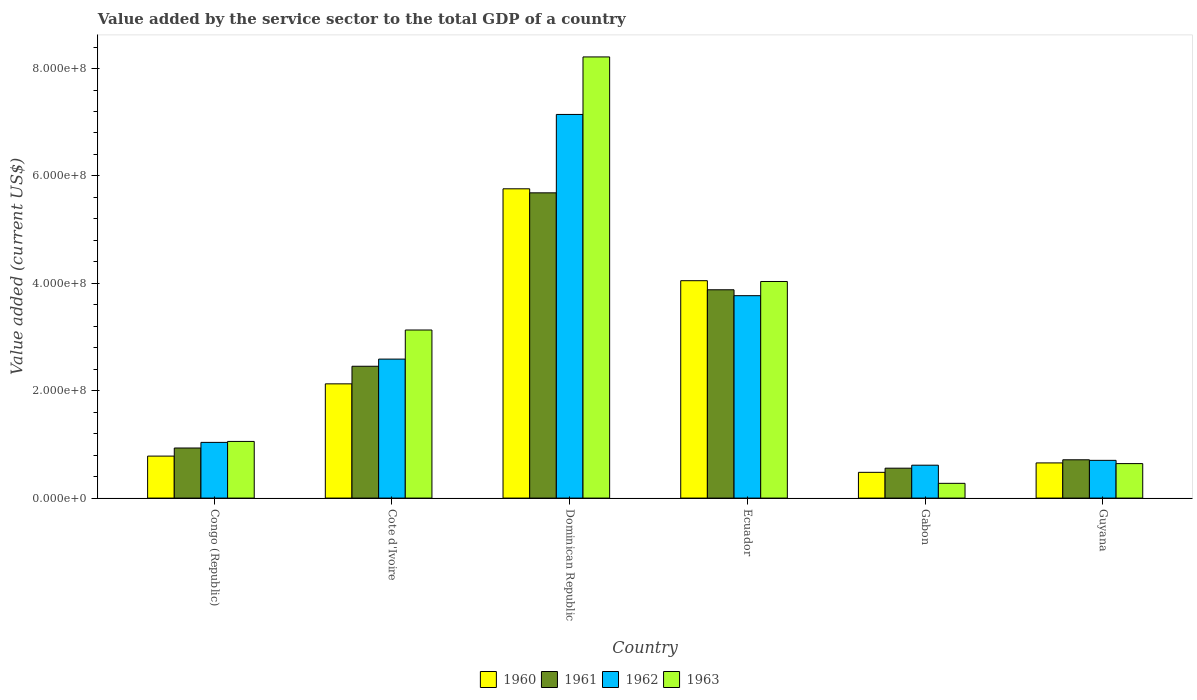Are the number of bars per tick equal to the number of legend labels?
Provide a succinct answer. Yes. Are the number of bars on each tick of the X-axis equal?
Offer a very short reply. Yes. How many bars are there on the 1st tick from the left?
Make the answer very short. 4. What is the label of the 1st group of bars from the left?
Provide a succinct answer. Congo (Republic). What is the value added by the service sector to the total GDP in 1961 in Guyana?
Your answer should be compact. 7.13e+07. Across all countries, what is the maximum value added by the service sector to the total GDP in 1962?
Provide a succinct answer. 7.14e+08. Across all countries, what is the minimum value added by the service sector to the total GDP in 1960?
Make the answer very short. 4.80e+07. In which country was the value added by the service sector to the total GDP in 1963 maximum?
Provide a succinct answer. Dominican Republic. In which country was the value added by the service sector to the total GDP in 1961 minimum?
Your response must be concise. Gabon. What is the total value added by the service sector to the total GDP in 1960 in the graph?
Your response must be concise. 1.39e+09. What is the difference between the value added by the service sector to the total GDP in 1962 in Congo (Republic) and that in Guyana?
Ensure brevity in your answer.  3.35e+07. What is the difference between the value added by the service sector to the total GDP in 1960 in Congo (Republic) and the value added by the service sector to the total GDP in 1962 in Cote d'Ivoire?
Your answer should be very brief. -1.81e+08. What is the average value added by the service sector to the total GDP in 1962 per country?
Your answer should be compact. 2.64e+08. What is the difference between the value added by the service sector to the total GDP of/in 1962 and value added by the service sector to the total GDP of/in 1960 in Congo (Republic)?
Make the answer very short. 2.55e+07. What is the ratio of the value added by the service sector to the total GDP in 1962 in Dominican Republic to that in Ecuador?
Your answer should be compact. 1.9. Is the value added by the service sector to the total GDP in 1961 in Congo (Republic) less than that in Cote d'Ivoire?
Provide a short and direct response. Yes. What is the difference between the highest and the second highest value added by the service sector to the total GDP in 1960?
Ensure brevity in your answer.  -1.71e+08. What is the difference between the highest and the lowest value added by the service sector to the total GDP in 1960?
Provide a short and direct response. 5.28e+08. In how many countries, is the value added by the service sector to the total GDP in 1960 greater than the average value added by the service sector to the total GDP in 1960 taken over all countries?
Your response must be concise. 2. Is the sum of the value added by the service sector to the total GDP in 1962 in Dominican Republic and Gabon greater than the maximum value added by the service sector to the total GDP in 1961 across all countries?
Provide a short and direct response. Yes. Is it the case that in every country, the sum of the value added by the service sector to the total GDP in 1962 and value added by the service sector to the total GDP in 1961 is greater than the sum of value added by the service sector to the total GDP in 1960 and value added by the service sector to the total GDP in 1963?
Offer a terse response. No. What does the 4th bar from the left in Ecuador represents?
Your answer should be compact. 1963. What does the 1st bar from the right in Gabon represents?
Provide a succinct answer. 1963. Is it the case that in every country, the sum of the value added by the service sector to the total GDP in 1961 and value added by the service sector to the total GDP in 1960 is greater than the value added by the service sector to the total GDP in 1962?
Provide a short and direct response. Yes. How many bars are there?
Keep it short and to the point. 24. How many countries are there in the graph?
Your response must be concise. 6. Are the values on the major ticks of Y-axis written in scientific E-notation?
Your response must be concise. Yes. Does the graph contain grids?
Provide a short and direct response. No. Where does the legend appear in the graph?
Your response must be concise. Bottom center. What is the title of the graph?
Your response must be concise. Value added by the service sector to the total GDP of a country. Does "1960" appear as one of the legend labels in the graph?
Make the answer very short. Yes. What is the label or title of the Y-axis?
Provide a short and direct response. Value added (current US$). What is the Value added (current US$) of 1960 in Congo (Republic)?
Keep it short and to the point. 7.82e+07. What is the Value added (current US$) of 1961 in Congo (Republic)?
Make the answer very short. 9.33e+07. What is the Value added (current US$) in 1962 in Congo (Republic)?
Give a very brief answer. 1.04e+08. What is the Value added (current US$) in 1963 in Congo (Republic)?
Your response must be concise. 1.06e+08. What is the Value added (current US$) of 1960 in Cote d'Ivoire?
Give a very brief answer. 2.13e+08. What is the Value added (current US$) of 1961 in Cote d'Ivoire?
Your answer should be compact. 2.46e+08. What is the Value added (current US$) in 1962 in Cote d'Ivoire?
Keep it short and to the point. 2.59e+08. What is the Value added (current US$) in 1963 in Cote d'Ivoire?
Give a very brief answer. 3.13e+08. What is the Value added (current US$) in 1960 in Dominican Republic?
Offer a terse response. 5.76e+08. What is the Value added (current US$) of 1961 in Dominican Republic?
Your answer should be compact. 5.68e+08. What is the Value added (current US$) of 1962 in Dominican Republic?
Offer a terse response. 7.14e+08. What is the Value added (current US$) of 1963 in Dominican Republic?
Offer a very short reply. 8.22e+08. What is the Value added (current US$) in 1960 in Ecuador?
Make the answer very short. 4.05e+08. What is the Value added (current US$) in 1961 in Ecuador?
Make the answer very short. 3.88e+08. What is the Value added (current US$) of 1962 in Ecuador?
Provide a succinct answer. 3.77e+08. What is the Value added (current US$) in 1963 in Ecuador?
Your answer should be compact. 4.03e+08. What is the Value added (current US$) of 1960 in Gabon?
Provide a short and direct response. 4.80e+07. What is the Value added (current US$) of 1961 in Gabon?
Your answer should be compact. 5.57e+07. What is the Value added (current US$) of 1962 in Gabon?
Your answer should be compact. 6.13e+07. What is the Value added (current US$) in 1963 in Gabon?
Give a very brief answer. 2.75e+07. What is the Value added (current US$) of 1960 in Guyana?
Give a very brief answer. 6.55e+07. What is the Value added (current US$) of 1961 in Guyana?
Give a very brief answer. 7.13e+07. What is the Value added (current US$) in 1962 in Guyana?
Provide a succinct answer. 7.03e+07. What is the Value added (current US$) of 1963 in Guyana?
Offer a terse response. 6.42e+07. Across all countries, what is the maximum Value added (current US$) of 1960?
Provide a short and direct response. 5.76e+08. Across all countries, what is the maximum Value added (current US$) of 1961?
Provide a succinct answer. 5.68e+08. Across all countries, what is the maximum Value added (current US$) in 1962?
Offer a very short reply. 7.14e+08. Across all countries, what is the maximum Value added (current US$) of 1963?
Offer a terse response. 8.22e+08. Across all countries, what is the minimum Value added (current US$) of 1960?
Your answer should be very brief. 4.80e+07. Across all countries, what is the minimum Value added (current US$) of 1961?
Keep it short and to the point. 5.57e+07. Across all countries, what is the minimum Value added (current US$) in 1962?
Offer a terse response. 6.13e+07. Across all countries, what is the minimum Value added (current US$) of 1963?
Provide a short and direct response. 2.75e+07. What is the total Value added (current US$) of 1960 in the graph?
Your response must be concise. 1.39e+09. What is the total Value added (current US$) in 1961 in the graph?
Keep it short and to the point. 1.42e+09. What is the total Value added (current US$) of 1962 in the graph?
Make the answer very short. 1.59e+09. What is the total Value added (current US$) of 1963 in the graph?
Ensure brevity in your answer.  1.74e+09. What is the difference between the Value added (current US$) in 1960 in Congo (Republic) and that in Cote d'Ivoire?
Offer a very short reply. -1.35e+08. What is the difference between the Value added (current US$) of 1961 in Congo (Republic) and that in Cote d'Ivoire?
Your answer should be very brief. -1.52e+08. What is the difference between the Value added (current US$) of 1962 in Congo (Republic) and that in Cote d'Ivoire?
Offer a very short reply. -1.55e+08. What is the difference between the Value added (current US$) in 1963 in Congo (Republic) and that in Cote d'Ivoire?
Your answer should be very brief. -2.08e+08. What is the difference between the Value added (current US$) of 1960 in Congo (Republic) and that in Dominican Republic?
Ensure brevity in your answer.  -4.98e+08. What is the difference between the Value added (current US$) of 1961 in Congo (Republic) and that in Dominican Republic?
Provide a short and direct response. -4.75e+08. What is the difference between the Value added (current US$) in 1962 in Congo (Republic) and that in Dominican Republic?
Give a very brief answer. -6.11e+08. What is the difference between the Value added (current US$) of 1963 in Congo (Republic) and that in Dominican Republic?
Give a very brief answer. -7.16e+08. What is the difference between the Value added (current US$) of 1960 in Congo (Republic) and that in Ecuador?
Provide a succinct answer. -3.27e+08. What is the difference between the Value added (current US$) of 1961 in Congo (Republic) and that in Ecuador?
Your answer should be compact. -2.95e+08. What is the difference between the Value added (current US$) of 1962 in Congo (Republic) and that in Ecuador?
Provide a succinct answer. -2.73e+08. What is the difference between the Value added (current US$) in 1963 in Congo (Republic) and that in Ecuador?
Ensure brevity in your answer.  -2.98e+08. What is the difference between the Value added (current US$) in 1960 in Congo (Republic) and that in Gabon?
Your answer should be very brief. 3.03e+07. What is the difference between the Value added (current US$) in 1961 in Congo (Republic) and that in Gabon?
Provide a succinct answer. 3.76e+07. What is the difference between the Value added (current US$) in 1962 in Congo (Republic) and that in Gabon?
Offer a very short reply. 4.25e+07. What is the difference between the Value added (current US$) in 1963 in Congo (Republic) and that in Gabon?
Provide a short and direct response. 7.81e+07. What is the difference between the Value added (current US$) in 1960 in Congo (Republic) and that in Guyana?
Your answer should be very brief. 1.27e+07. What is the difference between the Value added (current US$) in 1961 in Congo (Republic) and that in Guyana?
Your answer should be very brief. 2.19e+07. What is the difference between the Value added (current US$) of 1962 in Congo (Republic) and that in Guyana?
Give a very brief answer. 3.35e+07. What is the difference between the Value added (current US$) in 1963 in Congo (Republic) and that in Guyana?
Provide a short and direct response. 4.13e+07. What is the difference between the Value added (current US$) of 1960 in Cote d'Ivoire and that in Dominican Republic?
Make the answer very short. -3.63e+08. What is the difference between the Value added (current US$) of 1961 in Cote d'Ivoire and that in Dominican Republic?
Ensure brevity in your answer.  -3.23e+08. What is the difference between the Value added (current US$) of 1962 in Cote d'Ivoire and that in Dominican Republic?
Your response must be concise. -4.56e+08. What is the difference between the Value added (current US$) of 1963 in Cote d'Ivoire and that in Dominican Republic?
Make the answer very short. -5.09e+08. What is the difference between the Value added (current US$) of 1960 in Cote d'Ivoire and that in Ecuador?
Make the answer very short. -1.92e+08. What is the difference between the Value added (current US$) of 1961 in Cote d'Ivoire and that in Ecuador?
Your answer should be very brief. -1.42e+08. What is the difference between the Value added (current US$) in 1962 in Cote d'Ivoire and that in Ecuador?
Make the answer very short. -1.18e+08. What is the difference between the Value added (current US$) in 1963 in Cote d'Ivoire and that in Ecuador?
Your response must be concise. -9.04e+07. What is the difference between the Value added (current US$) of 1960 in Cote d'Ivoire and that in Gabon?
Ensure brevity in your answer.  1.65e+08. What is the difference between the Value added (current US$) in 1961 in Cote d'Ivoire and that in Gabon?
Make the answer very short. 1.90e+08. What is the difference between the Value added (current US$) of 1962 in Cote d'Ivoire and that in Gabon?
Make the answer very short. 1.98e+08. What is the difference between the Value added (current US$) of 1963 in Cote d'Ivoire and that in Gabon?
Provide a succinct answer. 2.86e+08. What is the difference between the Value added (current US$) of 1960 in Cote d'Ivoire and that in Guyana?
Ensure brevity in your answer.  1.47e+08. What is the difference between the Value added (current US$) of 1961 in Cote d'Ivoire and that in Guyana?
Offer a very short reply. 1.74e+08. What is the difference between the Value added (current US$) in 1962 in Cote d'Ivoire and that in Guyana?
Keep it short and to the point. 1.89e+08. What is the difference between the Value added (current US$) in 1963 in Cote d'Ivoire and that in Guyana?
Give a very brief answer. 2.49e+08. What is the difference between the Value added (current US$) in 1960 in Dominican Republic and that in Ecuador?
Your answer should be compact. 1.71e+08. What is the difference between the Value added (current US$) in 1961 in Dominican Republic and that in Ecuador?
Ensure brevity in your answer.  1.81e+08. What is the difference between the Value added (current US$) in 1962 in Dominican Republic and that in Ecuador?
Provide a short and direct response. 3.38e+08. What is the difference between the Value added (current US$) in 1963 in Dominican Republic and that in Ecuador?
Your answer should be compact. 4.18e+08. What is the difference between the Value added (current US$) in 1960 in Dominican Republic and that in Gabon?
Your answer should be compact. 5.28e+08. What is the difference between the Value added (current US$) of 1961 in Dominican Republic and that in Gabon?
Offer a very short reply. 5.13e+08. What is the difference between the Value added (current US$) of 1962 in Dominican Republic and that in Gabon?
Offer a terse response. 6.53e+08. What is the difference between the Value added (current US$) of 1963 in Dominican Republic and that in Gabon?
Keep it short and to the point. 7.94e+08. What is the difference between the Value added (current US$) of 1960 in Dominican Republic and that in Guyana?
Your response must be concise. 5.10e+08. What is the difference between the Value added (current US$) in 1961 in Dominican Republic and that in Guyana?
Your answer should be very brief. 4.97e+08. What is the difference between the Value added (current US$) in 1962 in Dominican Republic and that in Guyana?
Your answer should be very brief. 6.44e+08. What is the difference between the Value added (current US$) of 1963 in Dominican Republic and that in Guyana?
Your answer should be compact. 7.57e+08. What is the difference between the Value added (current US$) in 1960 in Ecuador and that in Gabon?
Offer a very short reply. 3.57e+08. What is the difference between the Value added (current US$) in 1961 in Ecuador and that in Gabon?
Offer a terse response. 3.32e+08. What is the difference between the Value added (current US$) in 1962 in Ecuador and that in Gabon?
Offer a very short reply. 3.16e+08. What is the difference between the Value added (current US$) of 1963 in Ecuador and that in Gabon?
Provide a short and direct response. 3.76e+08. What is the difference between the Value added (current US$) in 1960 in Ecuador and that in Guyana?
Provide a succinct answer. 3.39e+08. What is the difference between the Value added (current US$) of 1961 in Ecuador and that in Guyana?
Give a very brief answer. 3.17e+08. What is the difference between the Value added (current US$) in 1962 in Ecuador and that in Guyana?
Give a very brief answer. 3.07e+08. What is the difference between the Value added (current US$) in 1963 in Ecuador and that in Guyana?
Keep it short and to the point. 3.39e+08. What is the difference between the Value added (current US$) of 1960 in Gabon and that in Guyana?
Ensure brevity in your answer.  -1.76e+07. What is the difference between the Value added (current US$) of 1961 in Gabon and that in Guyana?
Offer a terse response. -1.56e+07. What is the difference between the Value added (current US$) in 1962 in Gabon and that in Guyana?
Offer a terse response. -9.03e+06. What is the difference between the Value added (current US$) in 1963 in Gabon and that in Guyana?
Your answer should be very brief. -3.68e+07. What is the difference between the Value added (current US$) of 1960 in Congo (Republic) and the Value added (current US$) of 1961 in Cote d'Ivoire?
Offer a very short reply. -1.67e+08. What is the difference between the Value added (current US$) in 1960 in Congo (Republic) and the Value added (current US$) in 1962 in Cote d'Ivoire?
Your answer should be very brief. -1.81e+08. What is the difference between the Value added (current US$) in 1960 in Congo (Republic) and the Value added (current US$) in 1963 in Cote d'Ivoire?
Ensure brevity in your answer.  -2.35e+08. What is the difference between the Value added (current US$) in 1961 in Congo (Republic) and the Value added (current US$) in 1962 in Cote d'Ivoire?
Offer a very short reply. -1.66e+08. What is the difference between the Value added (current US$) of 1961 in Congo (Republic) and the Value added (current US$) of 1963 in Cote d'Ivoire?
Offer a terse response. -2.20e+08. What is the difference between the Value added (current US$) of 1962 in Congo (Republic) and the Value added (current US$) of 1963 in Cote d'Ivoire?
Your answer should be compact. -2.09e+08. What is the difference between the Value added (current US$) of 1960 in Congo (Republic) and the Value added (current US$) of 1961 in Dominican Republic?
Give a very brief answer. -4.90e+08. What is the difference between the Value added (current US$) of 1960 in Congo (Republic) and the Value added (current US$) of 1962 in Dominican Republic?
Offer a terse response. -6.36e+08. What is the difference between the Value added (current US$) in 1960 in Congo (Republic) and the Value added (current US$) in 1963 in Dominican Republic?
Offer a terse response. -7.43e+08. What is the difference between the Value added (current US$) in 1961 in Congo (Republic) and the Value added (current US$) in 1962 in Dominican Republic?
Provide a succinct answer. -6.21e+08. What is the difference between the Value added (current US$) of 1961 in Congo (Republic) and the Value added (current US$) of 1963 in Dominican Republic?
Provide a short and direct response. -7.28e+08. What is the difference between the Value added (current US$) in 1962 in Congo (Republic) and the Value added (current US$) in 1963 in Dominican Republic?
Your response must be concise. -7.18e+08. What is the difference between the Value added (current US$) in 1960 in Congo (Republic) and the Value added (current US$) in 1961 in Ecuador?
Your response must be concise. -3.10e+08. What is the difference between the Value added (current US$) of 1960 in Congo (Republic) and the Value added (current US$) of 1962 in Ecuador?
Ensure brevity in your answer.  -2.99e+08. What is the difference between the Value added (current US$) in 1960 in Congo (Republic) and the Value added (current US$) in 1963 in Ecuador?
Ensure brevity in your answer.  -3.25e+08. What is the difference between the Value added (current US$) of 1961 in Congo (Republic) and the Value added (current US$) of 1962 in Ecuador?
Offer a terse response. -2.84e+08. What is the difference between the Value added (current US$) in 1961 in Congo (Republic) and the Value added (current US$) in 1963 in Ecuador?
Offer a terse response. -3.10e+08. What is the difference between the Value added (current US$) of 1962 in Congo (Republic) and the Value added (current US$) of 1963 in Ecuador?
Offer a very short reply. -3.00e+08. What is the difference between the Value added (current US$) in 1960 in Congo (Republic) and the Value added (current US$) in 1961 in Gabon?
Give a very brief answer. 2.25e+07. What is the difference between the Value added (current US$) of 1960 in Congo (Republic) and the Value added (current US$) of 1962 in Gabon?
Offer a terse response. 1.70e+07. What is the difference between the Value added (current US$) of 1960 in Congo (Republic) and the Value added (current US$) of 1963 in Gabon?
Provide a succinct answer. 5.07e+07. What is the difference between the Value added (current US$) of 1961 in Congo (Republic) and the Value added (current US$) of 1962 in Gabon?
Your answer should be compact. 3.20e+07. What is the difference between the Value added (current US$) of 1961 in Congo (Republic) and the Value added (current US$) of 1963 in Gabon?
Provide a short and direct response. 6.58e+07. What is the difference between the Value added (current US$) of 1962 in Congo (Republic) and the Value added (current US$) of 1963 in Gabon?
Offer a terse response. 7.63e+07. What is the difference between the Value added (current US$) in 1960 in Congo (Republic) and the Value added (current US$) in 1961 in Guyana?
Your answer should be compact. 6.87e+06. What is the difference between the Value added (current US$) in 1960 in Congo (Republic) and the Value added (current US$) in 1962 in Guyana?
Provide a short and direct response. 7.92e+06. What is the difference between the Value added (current US$) of 1960 in Congo (Republic) and the Value added (current US$) of 1963 in Guyana?
Offer a terse response. 1.40e+07. What is the difference between the Value added (current US$) of 1961 in Congo (Republic) and the Value added (current US$) of 1962 in Guyana?
Offer a terse response. 2.30e+07. What is the difference between the Value added (current US$) of 1961 in Congo (Republic) and the Value added (current US$) of 1963 in Guyana?
Ensure brevity in your answer.  2.91e+07. What is the difference between the Value added (current US$) in 1962 in Congo (Republic) and the Value added (current US$) in 1963 in Guyana?
Provide a succinct answer. 3.95e+07. What is the difference between the Value added (current US$) in 1960 in Cote d'Ivoire and the Value added (current US$) in 1961 in Dominican Republic?
Your response must be concise. -3.56e+08. What is the difference between the Value added (current US$) in 1960 in Cote d'Ivoire and the Value added (current US$) in 1962 in Dominican Republic?
Ensure brevity in your answer.  -5.02e+08. What is the difference between the Value added (current US$) of 1960 in Cote d'Ivoire and the Value added (current US$) of 1963 in Dominican Republic?
Offer a terse response. -6.09e+08. What is the difference between the Value added (current US$) of 1961 in Cote d'Ivoire and the Value added (current US$) of 1962 in Dominican Republic?
Your answer should be very brief. -4.69e+08. What is the difference between the Value added (current US$) of 1961 in Cote d'Ivoire and the Value added (current US$) of 1963 in Dominican Republic?
Your answer should be compact. -5.76e+08. What is the difference between the Value added (current US$) in 1962 in Cote d'Ivoire and the Value added (current US$) in 1963 in Dominican Republic?
Your answer should be compact. -5.63e+08. What is the difference between the Value added (current US$) in 1960 in Cote d'Ivoire and the Value added (current US$) in 1961 in Ecuador?
Provide a short and direct response. -1.75e+08. What is the difference between the Value added (current US$) in 1960 in Cote d'Ivoire and the Value added (current US$) in 1962 in Ecuador?
Offer a terse response. -1.64e+08. What is the difference between the Value added (current US$) in 1960 in Cote d'Ivoire and the Value added (current US$) in 1963 in Ecuador?
Your answer should be very brief. -1.91e+08. What is the difference between the Value added (current US$) in 1961 in Cote d'Ivoire and the Value added (current US$) in 1962 in Ecuador?
Your answer should be compact. -1.31e+08. What is the difference between the Value added (current US$) of 1961 in Cote d'Ivoire and the Value added (current US$) of 1963 in Ecuador?
Make the answer very short. -1.58e+08. What is the difference between the Value added (current US$) of 1962 in Cote d'Ivoire and the Value added (current US$) of 1963 in Ecuador?
Ensure brevity in your answer.  -1.45e+08. What is the difference between the Value added (current US$) of 1960 in Cote d'Ivoire and the Value added (current US$) of 1961 in Gabon?
Make the answer very short. 1.57e+08. What is the difference between the Value added (current US$) in 1960 in Cote d'Ivoire and the Value added (current US$) in 1962 in Gabon?
Your answer should be very brief. 1.52e+08. What is the difference between the Value added (current US$) in 1960 in Cote d'Ivoire and the Value added (current US$) in 1963 in Gabon?
Make the answer very short. 1.85e+08. What is the difference between the Value added (current US$) of 1961 in Cote d'Ivoire and the Value added (current US$) of 1962 in Gabon?
Your answer should be compact. 1.84e+08. What is the difference between the Value added (current US$) of 1961 in Cote d'Ivoire and the Value added (current US$) of 1963 in Gabon?
Your response must be concise. 2.18e+08. What is the difference between the Value added (current US$) of 1962 in Cote d'Ivoire and the Value added (current US$) of 1963 in Gabon?
Your response must be concise. 2.31e+08. What is the difference between the Value added (current US$) of 1960 in Cote d'Ivoire and the Value added (current US$) of 1961 in Guyana?
Give a very brief answer. 1.41e+08. What is the difference between the Value added (current US$) of 1960 in Cote d'Ivoire and the Value added (current US$) of 1962 in Guyana?
Give a very brief answer. 1.42e+08. What is the difference between the Value added (current US$) in 1960 in Cote d'Ivoire and the Value added (current US$) in 1963 in Guyana?
Offer a terse response. 1.49e+08. What is the difference between the Value added (current US$) of 1961 in Cote d'Ivoire and the Value added (current US$) of 1962 in Guyana?
Make the answer very short. 1.75e+08. What is the difference between the Value added (current US$) of 1961 in Cote d'Ivoire and the Value added (current US$) of 1963 in Guyana?
Your response must be concise. 1.81e+08. What is the difference between the Value added (current US$) in 1962 in Cote d'Ivoire and the Value added (current US$) in 1963 in Guyana?
Your response must be concise. 1.95e+08. What is the difference between the Value added (current US$) in 1960 in Dominican Republic and the Value added (current US$) in 1961 in Ecuador?
Offer a very short reply. 1.88e+08. What is the difference between the Value added (current US$) in 1960 in Dominican Republic and the Value added (current US$) in 1962 in Ecuador?
Keep it short and to the point. 1.99e+08. What is the difference between the Value added (current US$) of 1960 in Dominican Republic and the Value added (current US$) of 1963 in Ecuador?
Give a very brief answer. 1.73e+08. What is the difference between the Value added (current US$) in 1961 in Dominican Republic and the Value added (current US$) in 1962 in Ecuador?
Provide a succinct answer. 1.92e+08. What is the difference between the Value added (current US$) of 1961 in Dominican Republic and the Value added (current US$) of 1963 in Ecuador?
Your answer should be compact. 1.65e+08. What is the difference between the Value added (current US$) of 1962 in Dominican Republic and the Value added (current US$) of 1963 in Ecuador?
Make the answer very short. 3.11e+08. What is the difference between the Value added (current US$) in 1960 in Dominican Republic and the Value added (current US$) in 1961 in Gabon?
Offer a very short reply. 5.20e+08. What is the difference between the Value added (current US$) in 1960 in Dominican Republic and the Value added (current US$) in 1962 in Gabon?
Offer a very short reply. 5.15e+08. What is the difference between the Value added (current US$) of 1960 in Dominican Republic and the Value added (current US$) of 1963 in Gabon?
Provide a succinct answer. 5.49e+08. What is the difference between the Value added (current US$) of 1961 in Dominican Republic and the Value added (current US$) of 1962 in Gabon?
Your answer should be very brief. 5.07e+08. What is the difference between the Value added (current US$) of 1961 in Dominican Republic and the Value added (current US$) of 1963 in Gabon?
Your answer should be very brief. 5.41e+08. What is the difference between the Value added (current US$) in 1962 in Dominican Republic and the Value added (current US$) in 1963 in Gabon?
Your answer should be compact. 6.87e+08. What is the difference between the Value added (current US$) of 1960 in Dominican Republic and the Value added (current US$) of 1961 in Guyana?
Provide a succinct answer. 5.05e+08. What is the difference between the Value added (current US$) of 1960 in Dominican Republic and the Value added (current US$) of 1962 in Guyana?
Provide a short and direct response. 5.06e+08. What is the difference between the Value added (current US$) of 1960 in Dominican Republic and the Value added (current US$) of 1963 in Guyana?
Your response must be concise. 5.12e+08. What is the difference between the Value added (current US$) of 1961 in Dominican Republic and the Value added (current US$) of 1962 in Guyana?
Offer a very short reply. 4.98e+08. What is the difference between the Value added (current US$) of 1961 in Dominican Republic and the Value added (current US$) of 1963 in Guyana?
Your response must be concise. 5.04e+08. What is the difference between the Value added (current US$) in 1962 in Dominican Republic and the Value added (current US$) in 1963 in Guyana?
Your answer should be compact. 6.50e+08. What is the difference between the Value added (current US$) of 1960 in Ecuador and the Value added (current US$) of 1961 in Gabon?
Offer a very short reply. 3.49e+08. What is the difference between the Value added (current US$) of 1960 in Ecuador and the Value added (current US$) of 1962 in Gabon?
Provide a short and direct response. 3.44e+08. What is the difference between the Value added (current US$) in 1960 in Ecuador and the Value added (current US$) in 1963 in Gabon?
Your answer should be compact. 3.77e+08. What is the difference between the Value added (current US$) in 1961 in Ecuador and the Value added (current US$) in 1962 in Gabon?
Your answer should be compact. 3.27e+08. What is the difference between the Value added (current US$) of 1961 in Ecuador and the Value added (current US$) of 1963 in Gabon?
Your answer should be compact. 3.60e+08. What is the difference between the Value added (current US$) of 1962 in Ecuador and the Value added (current US$) of 1963 in Gabon?
Offer a terse response. 3.49e+08. What is the difference between the Value added (current US$) in 1960 in Ecuador and the Value added (current US$) in 1961 in Guyana?
Offer a terse response. 3.34e+08. What is the difference between the Value added (current US$) of 1960 in Ecuador and the Value added (current US$) of 1962 in Guyana?
Your answer should be very brief. 3.35e+08. What is the difference between the Value added (current US$) in 1960 in Ecuador and the Value added (current US$) in 1963 in Guyana?
Ensure brevity in your answer.  3.41e+08. What is the difference between the Value added (current US$) in 1961 in Ecuador and the Value added (current US$) in 1962 in Guyana?
Your answer should be compact. 3.18e+08. What is the difference between the Value added (current US$) in 1961 in Ecuador and the Value added (current US$) in 1963 in Guyana?
Make the answer very short. 3.24e+08. What is the difference between the Value added (current US$) in 1962 in Ecuador and the Value added (current US$) in 1963 in Guyana?
Provide a succinct answer. 3.13e+08. What is the difference between the Value added (current US$) of 1960 in Gabon and the Value added (current US$) of 1961 in Guyana?
Your response must be concise. -2.34e+07. What is the difference between the Value added (current US$) in 1960 in Gabon and the Value added (current US$) in 1962 in Guyana?
Keep it short and to the point. -2.23e+07. What is the difference between the Value added (current US$) in 1960 in Gabon and the Value added (current US$) in 1963 in Guyana?
Your response must be concise. -1.63e+07. What is the difference between the Value added (current US$) of 1961 in Gabon and the Value added (current US$) of 1962 in Guyana?
Provide a succinct answer. -1.46e+07. What is the difference between the Value added (current US$) of 1961 in Gabon and the Value added (current US$) of 1963 in Guyana?
Provide a succinct answer. -8.53e+06. What is the difference between the Value added (current US$) in 1962 in Gabon and the Value added (current US$) in 1963 in Guyana?
Your answer should be very brief. -2.96e+06. What is the average Value added (current US$) of 1960 per country?
Ensure brevity in your answer.  2.31e+08. What is the average Value added (current US$) in 1961 per country?
Ensure brevity in your answer.  2.37e+08. What is the average Value added (current US$) in 1962 per country?
Provide a succinct answer. 2.64e+08. What is the average Value added (current US$) in 1963 per country?
Offer a very short reply. 2.89e+08. What is the difference between the Value added (current US$) of 1960 and Value added (current US$) of 1961 in Congo (Republic)?
Provide a succinct answer. -1.51e+07. What is the difference between the Value added (current US$) in 1960 and Value added (current US$) in 1962 in Congo (Republic)?
Your answer should be compact. -2.55e+07. What is the difference between the Value added (current US$) of 1960 and Value added (current US$) of 1963 in Congo (Republic)?
Your answer should be compact. -2.73e+07. What is the difference between the Value added (current US$) in 1961 and Value added (current US$) in 1962 in Congo (Republic)?
Provide a succinct answer. -1.05e+07. What is the difference between the Value added (current US$) of 1961 and Value added (current US$) of 1963 in Congo (Republic)?
Your answer should be very brief. -1.23e+07. What is the difference between the Value added (current US$) of 1962 and Value added (current US$) of 1963 in Congo (Republic)?
Offer a very short reply. -1.79e+06. What is the difference between the Value added (current US$) in 1960 and Value added (current US$) in 1961 in Cote d'Ivoire?
Your answer should be very brief. -3.28e+07. What is the difference between the Value added (current US$) of 1960 and Value added (current US$) of 1962 in Cote d'Ivoire?
Give a very brief answer. -4.61e+07. What is the difference between the Value added (current US$) in 1960 and Value added (current US$) in 1963 in Cote d'Ivoire?
Offer a terse response. -1.00e+08. What is the difference between the Value added (current US$) in 1961 and Value added (current US$) in 1962 in Cote d'Ivoire?
Provide a succinct answer. -1.33e+07. What is the difference between the Value added (current US$) of 1961 and Value added (current US$) of 1963 in Cote d'Ivoire?
Offer a very short reply. -6.75e+07. What is the difference between the Value added (current US$) in 1962 and Value added (current US$) in 1963 in Cote d'Ivoire?
Make the answer very short. -5.42e+07. What is the difference between the Value added (current US$) in 1960 and Value added (current US$) in 1961 in Dominican Republic?
Provide a short and direct response. 7.50e+06. What is the difference between the Value added (current US$) of 1960 and Value added (current US$) of 1962 in Dominican Republic?
Offer a very short reply. -1.39e+08. What is the difference between the Value added (current US$) in 1960 and Value added (current US$) in 1963 in Dominican Republic?
Your response must be concise. -2.46e+08. What is the difference between the Value added (current US$) of 1961 and Value added (current US$) of 1962 in Dominican Republic?
Your answer should be compact. -1.46e+08. What is the difference between the Value added (current US$) of 1961 and Value added (current US$) of 1963 in Dominican Republic?
Provide a succinct answer. -2.53e+08. What is the difference between the Value added (current US$) in 1962 and Value added (current US$) in 1963 in Dominican Republic?
Keep it short and to the point. -1.07e+08. What is the difference between the Value added (current US$) in 1960 and Value added (current US$) in 1961 in Ecuador?
Your response must be concise. 1.69e+07. What is the difference between the Value added (current US$) of 1960 and Value added (current US$) of 1962 in Ecuador?
Offer a terse response. 2.79e+07. What is the difference between the Value added (current US$) in 1960 and Value added (current US$) in 1963 in Ecuador?
Offer a terse response. 1.47e+06. What is the difference between the Value added (current US$) of 1961 and Value added (current US$) of 1962 in Ecuador?
Your answer should be very brief. 1.10e+07. What is the difference between the Value added (current US$) in 1961 and Value added (current US$) in 1963 in Ecuador?
Your answer should be very brief. -1.54e+07. What is the difference between the Value added (current US$) of 1962 and Value added (current US$) of 1963 in Ecuador?
Your answer should be very brief. -2.64e+07. What is the difference between the Value added (current US$) of 1960 and Value added (current US$) of 1961 in Gabon?
Provide a succinct answer. -7.74e+06. What is the difference between the Value added (current US$) of 1960 and Value added (current US$) of 1962 in Gabon?
Your response must be concise. -1.33e+07. What is the difference between the Value added (current US$) in 1960 and Value added (current US$) in 1963 in Gabon?
Keep it short and to the point. 2.05e+07. What is the difference between the Value added (current US$) in 1961 and Value added (current US$) in 1962 in Gabon?
Offer a terse response. -5.57e+06. What is the difference between the Value added (current US$) in 1961 and Value added (current US$) in 1963 in Gabon?
Your answer should be compact. 2.82e+07. What is the difference between the Value added (current US$) of 1962 and Value added (current US$) of 1963 in Gabon?
Offer a terse response. 3.38e+07. What is the difference between the Value added (current US$) of 1960 and Value added (current US$) of 1961 in Guyana?
Your response must be concise. -5.83e+06. What is the difference between the Value added (current US$) in 1960 and Value added (current US$) in 1962 in Guyana?
Make the answer very short. -4.78e+06. What is the difference between the Value added (current US$) in 1960 and Value added (current US$) in 1963 in Guyana?
Make the answer very short. 1.28e+06. What is the difference between the Value added (current US$) in 1961 and Value added (current US$) in 1962 in Guyana?
Make the answer very short. 1.05e+06. What is the difference between the Value added (current US$) of 1961 and Value added (current US$) of 1963 in Guyana?
Your answer should be compact. 7.12e+06. What is the difference between the Value added (current US$) in 1962 and Value added (current US$) in 1963 in Guyana?
Offer a terse response. 6.07e+06. What is the ratio of the Value added (current US$) in 1960 in Congo (Republic) to that in Cote d'Ivoire?
Your response must be concise. 0.37. What is the ratio of the Value added (current US$) of 1961 in Congo (Republic) to that in Cote d'Ivoire?
Your answer should be very brief. 0.38. What is the ratio of the Value added (current US$) in 1962 in Congo (Republic) to that in Cote d'Ivoire?
Your response must be concise. 0.4. What is the ratio of the Value added (current US$) of 1963 in Congo (Republic) to that in Cote d'Ivoire?
Your answer should be very brief. 0.34. What is the ratio of the Value added (current US$) of 1960 in Congo (Republic) to that in Dominican Republic?
Ensure brevity in your answer.  0.14. What is the ratio of the Value added (current US$) of 1961 in Congo (Republic) to that in Dominican Republic?
Offer a terse response. 0.16. What is the ratio of the Value added (current US$) of 1962 in Congo (Republic) to that in Dominican Republic?
Your response must be concise. 0.15. What is the ratio of the Value added (current US$) in 1963 in Congo (Republic) to that in Dominican Republic?
Your response must be concise. 0.13. What is the ratio of the Value added (current US$) in 1960 in Congo (Republic) to that in Ecuador?
Your answer should be very brief. 0.19. What is the ratio of the Value added (current US$) of 1961 in Congo (Republic) to that in Ecuador?
Your answer should be compact. 0.24. What is the ratio of the Value added (current US$) of 1962 in Congo (Republic) to that in Ecuador?
Offer a terse response. 0.28. What is the ratio of the Value added (current US$) in 1963 in Congo (Republic) to that in Ecuador?
Your answer should be compact. 0.26. What is the ratio of the Value added (current US$) of 1960 in Congo (Republic) to that in Gabon?
Offer a very short reply. 1.63. What is the ratio of the Value added (current US$) of 1961 in Congo (Republic) to that in Gabon?
Ensure brevity in your answer.  1.67. What is the ratio of the Value added (current US$) of 1962 in Congo (Republic) to that in Gabon?
Keep it short and to the point. 1.69. What is the ratio of the Value added (current US$) in 1963 in Congo (Republic) to that in Gabon?
Make the answer very short. 3.84. What is the ratio of the Value added (current US$) of 1960 in Congo (Republic) to that in Guyana?
Provide a short and direct response. 1.19. What is the ratio of the Value added (current US$) in 1961 in Congo (Republic) to that in Guyana?
Provide a short and direct response. 1.31. What is the ratio of the Value added (current US$) of 1962 in Congo (Republic) to that in Guyana?
Offer a terse response. 1.48. What is the ratio of the Value added (current US$) in 1963 in Congo (Republic) to that in Guyana?
Provide a short and direct response. 1.64. What is the ratio of the Value added (current US$) of 1960 in Cote d'Ivoire to that in Dominican Republic?
Provide a short and direct response. 0.37. What is the ratio of the Value added (current US$) of 1961 in Cote d'Ivoire to that in Dominican Republic?
Your answer should be very brief. 0.43. What is the ratio of the Value added (current US$) in 1962 in Cote d'Ivoire to that in Dominican Republic?
Your response must be concise. 0.36. What is the ratio of the Value added (current US$) in 1963 in Cote d'Ivoire to that in Dominican Republic?
Ensure brevity in your answer.  0.38. What is the ratio of the Value added (current US$) of 1960 in Cote d'Ivoire to that in Ecuador?
Keep it short and to the point. 0.53. What is the ratio of the Value added (current US$) of 1961 in Cote d'Ivoire to that in Ecuador?
Your answer should be very brief. 0.63. What is the ratio of the Value added (current US$) in 1962 in Cote d'Ivoire to that in Ecuador?
Keep it short and to the point. 0.69. What is the ratio of the Value added (current US$) in 1963 in Cote d'Ivoire to that in Ecuador?
Offer a terse response. 0.78. What is the ratio of the Value added (current US$) in 1960 in Cote d'Ivoire to that in Gabon?
Your answer should be compact. 4.44. What is the ratio of the Value added (current US$) in 1961 in Cote d'Ivoire to that in Gabon?
Make the answer very short. 4.41. What is the ratio of the Value added (current US$) in 1962 in Cote d'Ivoire to that in Gabon?
Give a very brief answer. 4.23. What is the ratio of the Value added (current US$) of 1963 in Cote d'Ivoire to that in Gabon?
Provide a short and direct response. 11.4. What is the ratio of the Value added (current US$) of 1960 in Cote d'Ivoire to that in Guyana?
Offer a terse response. 3.25. What is the ratio of the Value added (current US$) of 1961 in Cote d'Ivoire to that in Guyana?
Give a very brief answer. 3.44. What is the ratio of the Value added (current US$) of 1962 in Cote d'Ivoire to that in Guyana?
Your answer should be very brief. 3.68. What is the ratio of the Value added (current US$) of 1963 in Cote d'Ivoire to that in Guyana?
Make the answer very short. 4.87. What is the ratio of the Value added (current US$) of 1960 in Dominican Republic to that in Ecuador?
Offer a terse response. 1.42. What is the ratio of the Value added (current US$) of 1961 in Dominican Republic to that in Ecuador?
Your response must be concise. 1.47. What is the ratio of the Value added (current US$) of 1962 in Dominican Republic to that in Ecuador?
Your response must be concise. 1.9. What is the ratio of the Value added (current US$) in 1963 in Dominican Republic to that in Ecuador?
Offer a terse response. 2.04. What is the ratio of the Value added (current US$) in 1960 in Dominican Republic to that in Gabon?
Give a very brief answer. 12.01. What is the ratio of the Value added (current US$) in 1961 in Dominican Republic to that in Gabon?
Keep it short and to the point. 10.21. What is the ratio of the Value added (current US$) of 1962 in Dominican Republic to that in Gabon?
Give a very brief answer. 11.66. What is the ratio of the Value added (current US$) in 1963 in Dominican Republic to that in Gabon?
Your answer should be very brief. 29.91. What is the ratio of the Value added (current US$) of 1960 in Dominican Republic to that in Guyana?
Your answer should be very brief. 8.79. What is the ratio of the Value added (current US$) of 1961 in Dominican Republic to that in Guyana?
Offer a very short reply. 7.97. What is the ratio of the Value added (current US$) in 1962 in Dominican Republic to that in Guyana?
Provide a succinct answer. 10.16. What is the ratio of the Value added (current US$) of 1963 in Dominican Republic to that in Guyana?
Give a very brief answer. 12.79. What is the ratio of the Value added (current US$) of 1960 in Ecuador to that in Gabon?
Your answer should be compact. 8.44. What is the ratio of the Value added (current US$) in 1961 in Ecuador to that in Gabon?
Offer a terse response. 6.97. What is the ratio of the Value added (current US$) in 1962 in Ecuador to that in Gabon?
Provide a succinct answer. 6.15. What is the ratio of the Value added (current US$) in 1963 in Ecuador to that in Gabon?
Ensure brevity in your answer.  14.68. What is the ratio of the Value added (current US$) of 1960 in Ecuador to that in Guyana?
Offer a terse response. 6.18. What is the ratio of the Value added (current US$) of 1961 in Ecuador to that in Guyana?
Provide a short and direct response. 5.44. What is the ratio of the Value added (current US$) of 1962 in Ecuador to that in Guyana?
Offer a very short reply. 5.36. What is the ratio of the Value added (current US$) in 1963 in Ecuador to that in Guyana?
Offer a terse response. 6.28. What is the ratio of the Value added (current US$) in 1960 in Gabon to that in Guyana?
Your response must be concise. 0.73. What is the ratio of the Value added (current US$) of 1961 in Gabon to that in Guyana?
Give a very brief answer. 0.78. What is the ratio of the Value added (current US$) of 1962 in Gabon to that in Guyana?
Your answer should be very brief. 0.87. What is the ratio of the Value added (current US$) in 1963 in Gabon to that in Guyana?
Provide a short and direct response. 0.43. What is the difference between the highest and the second highest Value added (current US$) in 1960?
Ensure brevity in your answer.  1.71e+08. What is the difference between the highest and the second highest Value added (current US$) in 1961?
Make the answer very short. 1.81e+08. What is the difference between the highest and the second highest Value added (current US$) in 1962?
Your answer should be very brief. 3.38e+08. What is the difference between the highest and the second highest Value added (current US$) of 1963?
Offer a terse response. 4.18e+08. What is the difference between the highest and the lowest Value added (current US$) of 1960?
Provide a short and direct response. 5.28e+08. What is the difference between the highest and the lowest Value added (current US$) in 1961?
Offer a very short reply. 5.13e+08. What is the difference between the highest and the lowest Value added (current US$) in 1962?
Your answer should be very brief. 6.53e+08. What is the difference between the highest and the lowest Value added (current US$) of 1963?
Your answer should be compact. 7.94e+08. 